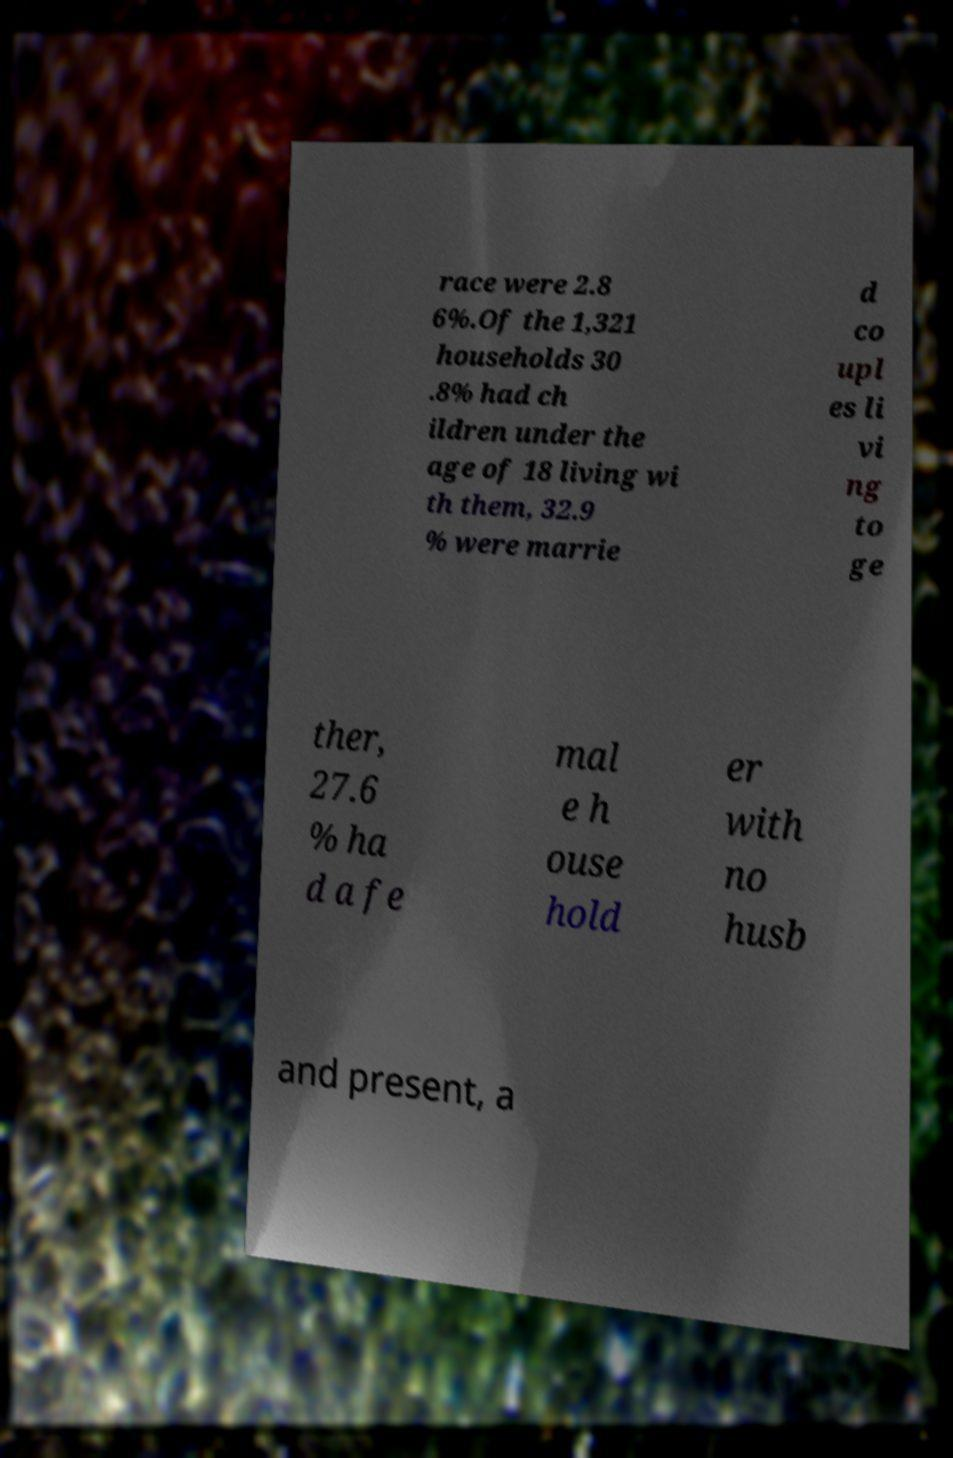Can you accurately transcribe the text from the provided image for me? race were 2.8 6%.Of the 1,321 households 30 .8% had ch ildren under the age of 18 living wi th them, 32.9 % were marrie d co upl es li vi ng to ge ther, 27.6 % ha d a fe mal e h ouse hold er with no husb and present, a 